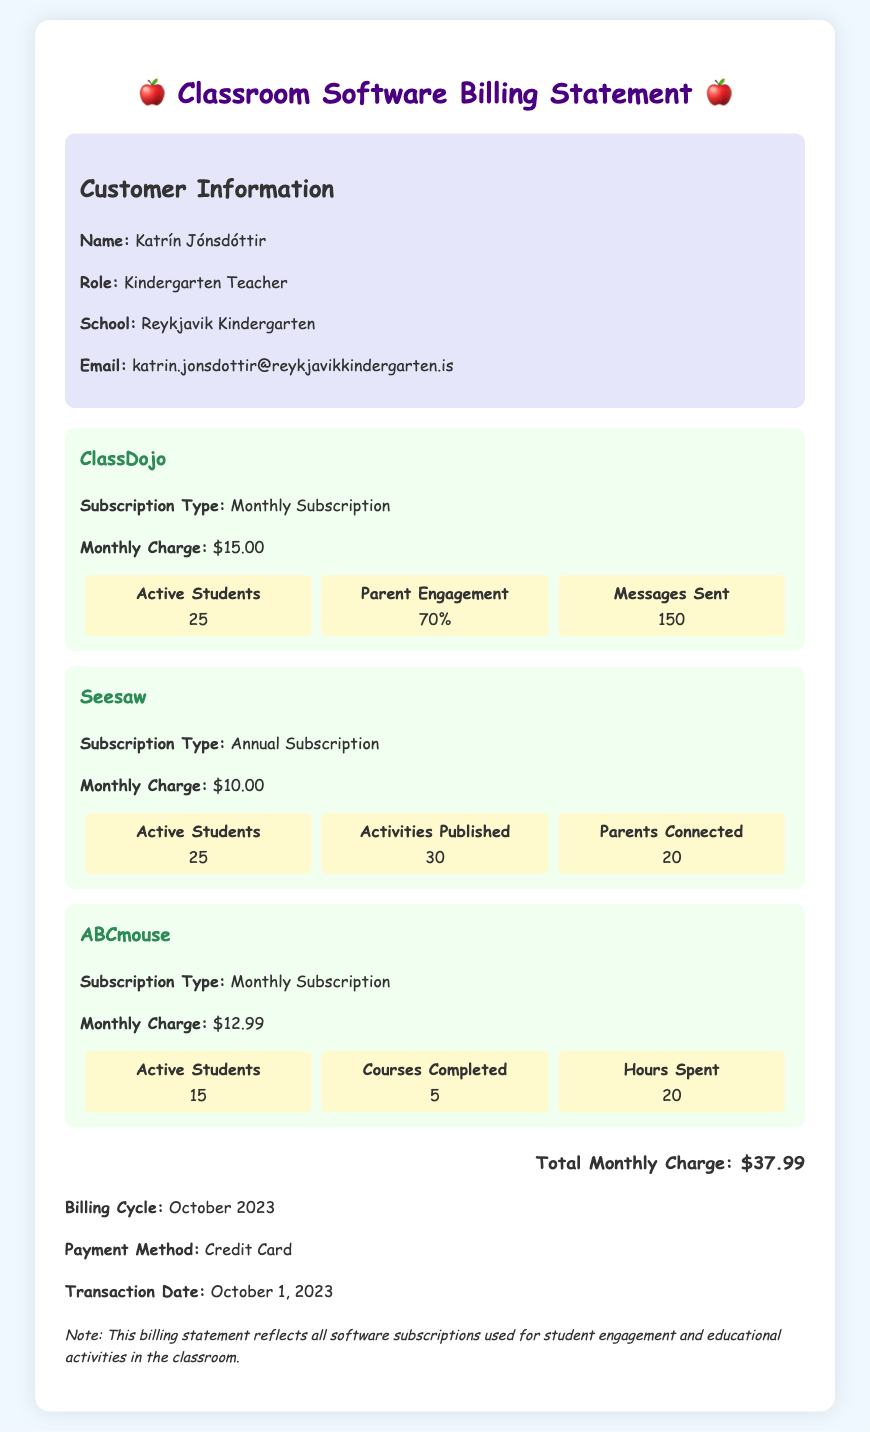What is the name of the customer? The customer's name is provided in the customer details section of the document.
Answer: Katrín Jónsdóttir What is the total monthly charge? The total monthly charge is summarized at the end of the billing statement.
Answer: $37.99 How many active students are using ClassDojo? The number of active students using ClassDojo is specified in the subscription section for ClassDojo.
Answer: 25 What is the subscription type for Seesaw? The subscription type for Seesaw is mentioned in its individual subscription section.
Answer: Annual Subscription What percentage of parent engagement is reported for ClassDojo? The percentage of parent engagement can be found in the usage statistics for ClassDojo.
Answer: 70% How many activities were published in Seesaw? The number of activities published is detailed in the usage stats for Seesaw.
Answer: 30 What payment method was used for this transaction? The payment method is provided near the end of the document.
Answer: Credit Card On what date was the transaction made? The transaction date is clearly listed in the billing details.
Answer: October 1, 2023 How many courses were completed on ABCmouse? The number of courses completed is included in the usage statistics for ABCmouse.
Answer: 5 